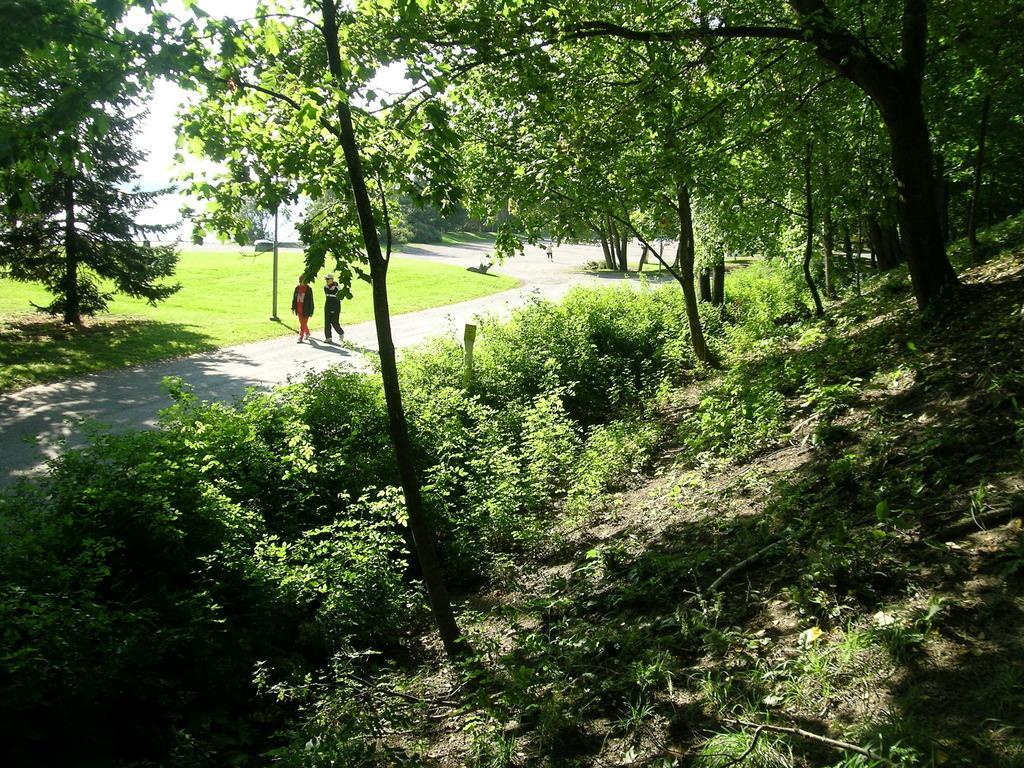Can you describe this image briefly? In this image on the left and right side, I can see the trees. In the middle I can see two people are walking on the road. 